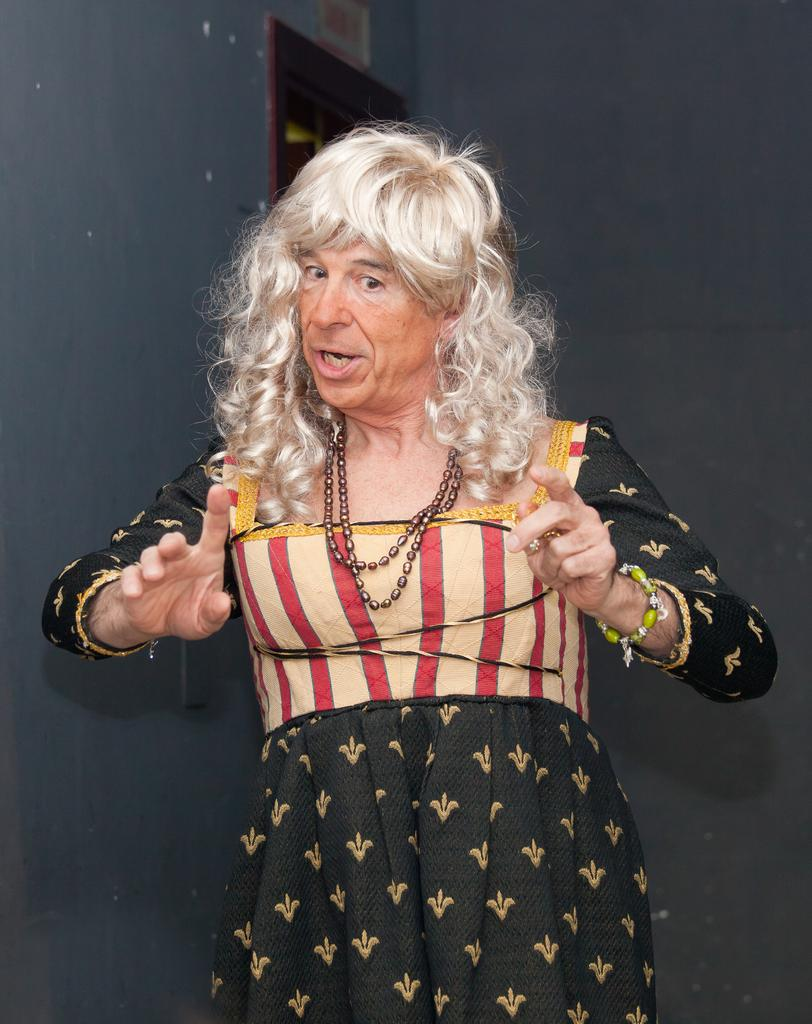Who is present in the image? There is a woman in the image. What is the woman wearing? The woman is wearing a black dress. What can be seen in the background of the image? There is a wall in the background of the image. What type of guitar is the woman playing in the image? There is no guitar present in the image; the woman is not playing any instrument. 